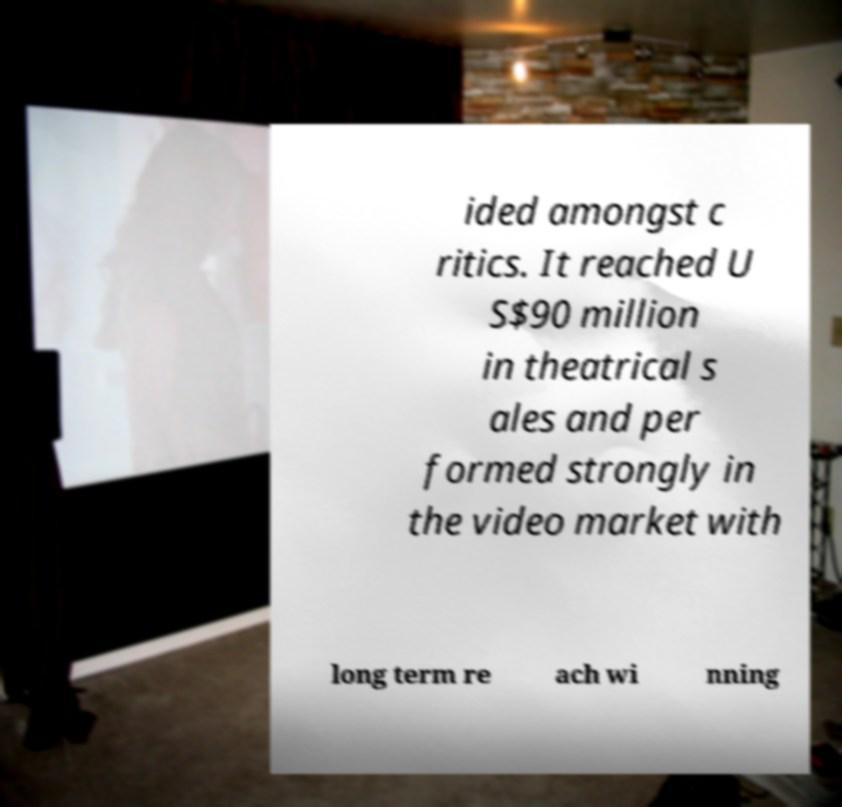What messages or text are displayed in this image? I need them in a readable, typed format. ided amongst c ritics. It reached U S$90 million in theatrical s ales and per formed strongly in the video market with long term re ach wi nning 